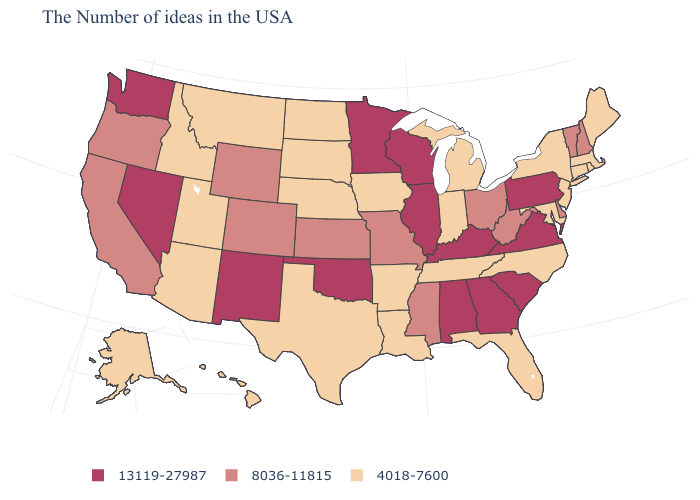Which states have the lowest value in the USA?
Be succinct. Maine, Massachusetts, Rhode Island, Connecticut, New York, New Jersey, Maryland, North Carolina, Florida, Michigan, Indiana, Tennessee, Louisiana, Arkansas, Iowa, Nebraska, Texas, South Dakota, North Dakota, Utah, Montana, Arizona, Idaho, Alaska, Hawaii. Does Maine have the same value as Connecticut?
Be succinct. Yes. Name the states that have a value in the range 8036-11815?
Short answer required. New Hampshire, Vermont, Delaware, West Virginia, Ohio, Mississippi, Missouri, Kansas, Wyoming, Colorado, California, Oregon. What is the value of Nevada?
Concise answer only. 13119-27987. Among the states that border Connecticut , which have the highest value?
Keep it brief. Massachusetts, Rhode Island, New York. What is the value of North Dakota?
Short answer required. 4018-7600. Does Alaska have the highest value in the West?
Give a very brief answer. No. What is the value of South Dakota?
Keep it brief. 4018-7600. What is the value of Wisconsin?
Be succinct. 13119-27987. What is the highest value in the USA?
Answer briefly. 13119-27987. Which states hav the highest value in the West?
Be succinct. New Mexico, Nevada, Washington. What is the value of Oklahoma?
Write a very short answer. 13119-27987. What is the lowest value in the South?
Concise answer only. 4018-7600. Does West Virginia have the highest value in the USA?
Give a very brief answer. No. What is the value of Massachusetts?
Answer briefly. 4018-7600. 